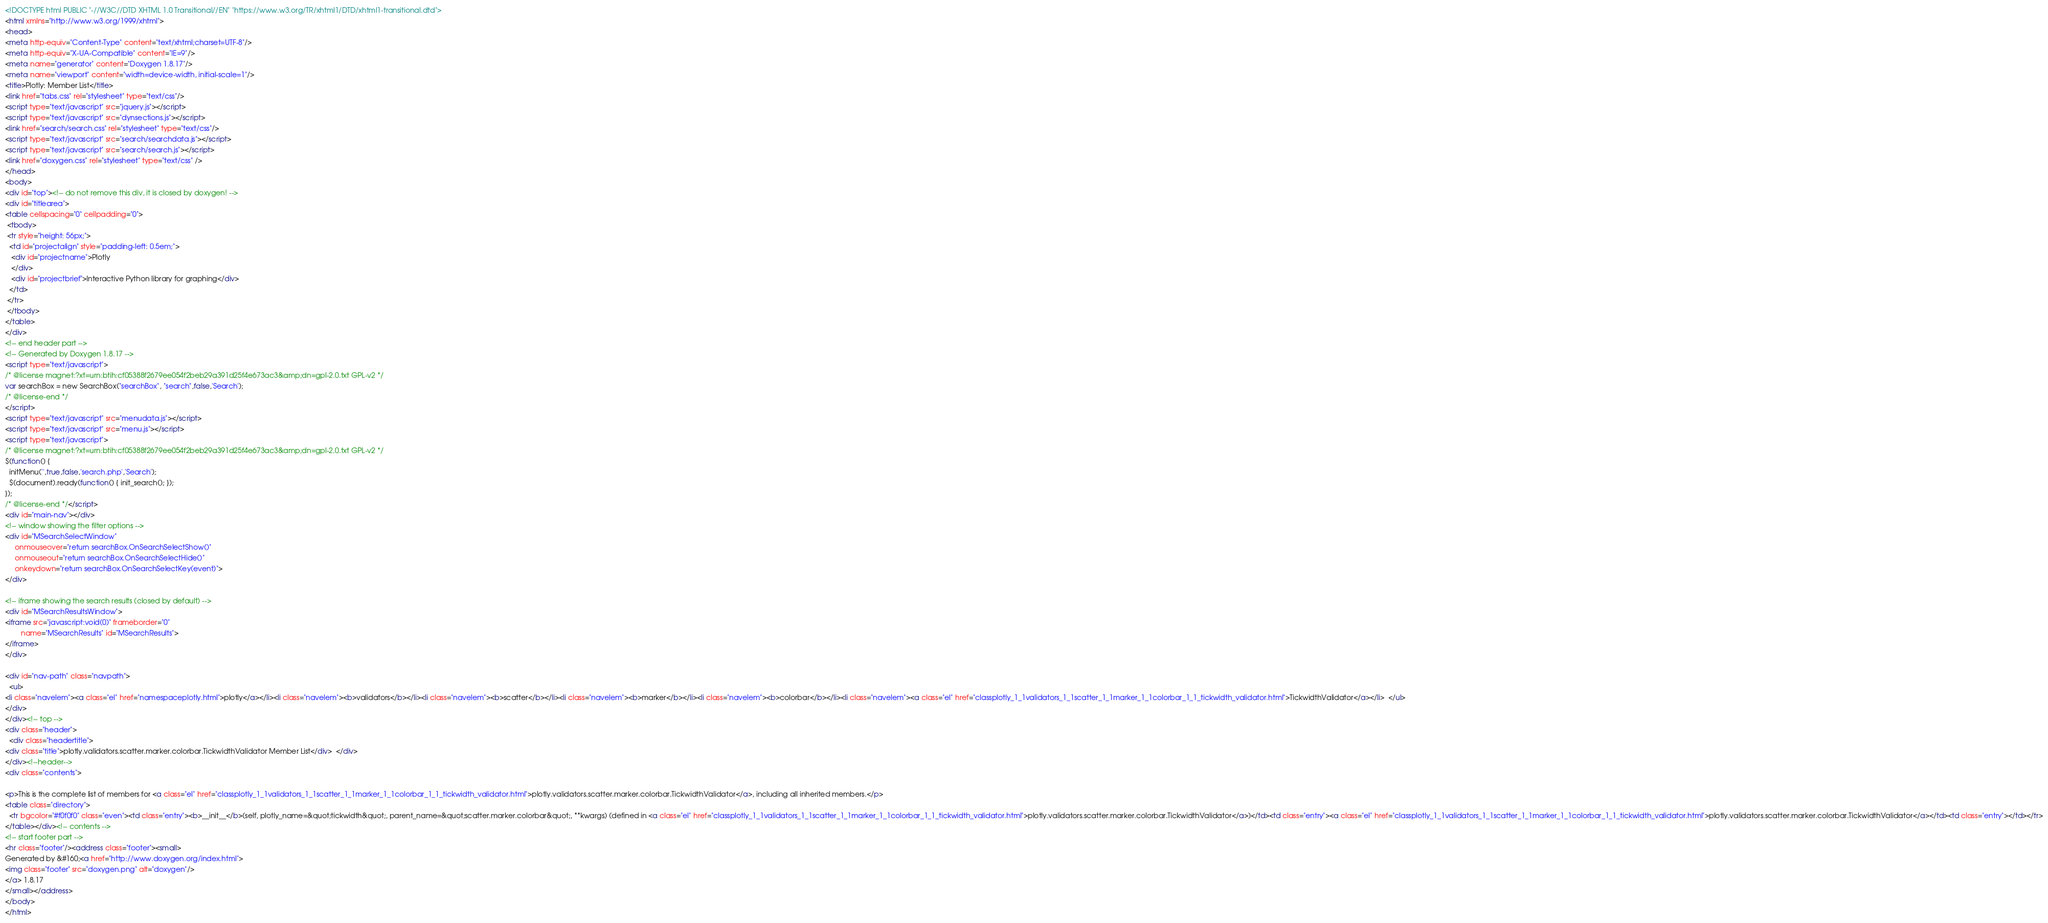<code> <loc_0><loc_0><loc_500><loc_500><_HTML_><!DOCTYPE html PUBLIC "-//W3C//DTD XHTML 1.0 Transitional//EN" "https://www.w3.org/TR/xhtml1/DTD/xhtml1-transitional.dtd">
<html xmlns="http://www.w3.org/1999/xhtml">
<head>
<meta http-equiv="Content-Type" content="text/xhtml;charset=UTF-8"/>
<meta http-equiv="X-UA-Compatible" content="IE=9"/>
<meta name="generator" content="Doxygen 1.8.17"/>
<meta name="viewport" content="width=device-width, initial-scale=1"/>
<title>Plotly: Member List</title>
<link href="tabs.css" rel="stylesheet" type="text/css"/>
<script type="text/javascript" src="jquery.js"></script>
<script type="text/javascript" src="dynsections.js"></script>
<link href="search/search.css" rel="stylesheet" type="text/css"/>
<script type="text/javascript" src="search/searchdata.js"></script>
<script type="text/javascript" src="search/search.js"></script>
<link href="doxygen.css" rel="stylesheet" type="text/css" />
</head>
<body>
<div id="top"><!-- do not remove this div, it is closed by doxygen! -->
<div id="titlearea">
<table cellspacing="0" cellpadding="0">
 <tbody>
 <tr style="height: 56px;">
  <td id="projectalign" style="padding-left: 0.5em;">
   <div id="projectname">Plotly
   </div>
   <div id="projectbrief">Interactive Python library for graphing</div>
  </td>
 </tr>
 </tbody>
</table>
</div>
<!-- end header part -->
<!-- Generated by Doxygen 1.8.17 -->
<script type="text/javascript">
/* @license magnet:?xt=urn:btih:cf05388f2679ee054f2beb29a391d25f4e673ac3&amp;dn=gpl-2.0.txt GPL-v2 */
var searchBox = new SearchBox("searchBox", "search",false,'Search');
/* @license-end */
</script>
<script type="text/javascript" src="menudata.js"></script>
<script type="text/javascript" src="menu.js"></script>
<script type="text/javascript">
/* @license magnet:?xt=urn:btih:cf05388f2679ee054f2beb29a391d25f4e673ac3&amp;dn=gpl-2.0.txt GPL-v2 */
$(function() {
  initMenu('',true,false,'search.php','Search');
  $(document).ready(function() { init_search(); });
});
/* @license-end */</script>
<div id="main-nav"></div>
<!-- window showing the filter options -->
<div id="MSearchSelectWindow"
     onmouseover="return searchBox.OnSearchSelectShow()"
     onmouseout="return searchBox.OnSearchSelectHide()"
     onkeydown="return searchBox.OnSearchSelectKey(event)">
</div>

<!-- iframe showing the search results (closed by default) -->
<div id="MSearchResultsWindow">
<iframe src="javascript:void(0)" frameborder="0" 
        name="MSearchResults" id="MSearchResults">
</iframe>
</div>

<div id="nav-path" class="navpath">
  <ul>
<li class="navelem"><a class="el" href="namespaceplotly.html">plotly</a></li><li class="navelem"><b>validators</b></li><li class="navelem"><b>scatter</b></li><li class="navelem"><b>marker</b></li><li class="navelem"><b>colorbar</b></li><li class="navelem"><a class="el" href="classplotly_1_1validators_1_1scatter_1_1marker_1_1colorbar_1_1_tickwidth_validator.html">TickwidthValidator</a></li>  </ul>
</div>
</div><!-- top -->
<div class="header">
  <div class="headertitle">
<div class="title">plotly.validators.scatter.marker.colorbar.TickwidthValidator Member List</div>  </div>
</div><!--header-->
<div class="contents">

<p>This is the complete list of members for <a class="el" href="classplotly_1_1validators_1_1scatter_1_1marker_1_1colorbar_1_1_tickwidth_validator.html">plotly.validators.scatter.marker.colorbar.TickwidthValidator</a>, including all inherited members.</p>
<table class="directory">
  <tr bgcolor="#f0f0f0" class="even"><td class="entry"><b>__init__</b>(self, plotly_name=&quot;tickwidth&quot;, parent_name=&quot;scatter.marker.colorbar&quot;, **kwargs) (defined in <a class="el" href="classplotly_1_1validators_1_1scatter_1_1marker_1_1colorbar_1_1_tickwidth_validator.html">plotly.validators.scatter.marker.colorbar.TickwidthValidator</a>)</td><td class="entry"><a class="el" href="classplotly_1_1validators_1_1scatter_1_1marker_1_1colorbar_1_1_tickwidth_validator.html">plotly.validators.scatter.marker.colorbar.TickwidthValidator</a></td><td class="entry"></td></tr>
</table></div><!-- contents -->
<!-- start footer part -->
<hr class="footer"/><address class="footer"><small>
Generated by &#160;<a href="http://www.doxygen.org/index.html">
<img class="footer" src="doxygen.png" alt="doxygen"/>
</a> 1.8.17
</small></address>
</body>
</html>
</code> 